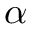Convert formula to latex. <formula><loc_0><loc_0><loc_500><loc_500>\alpha</formula> 